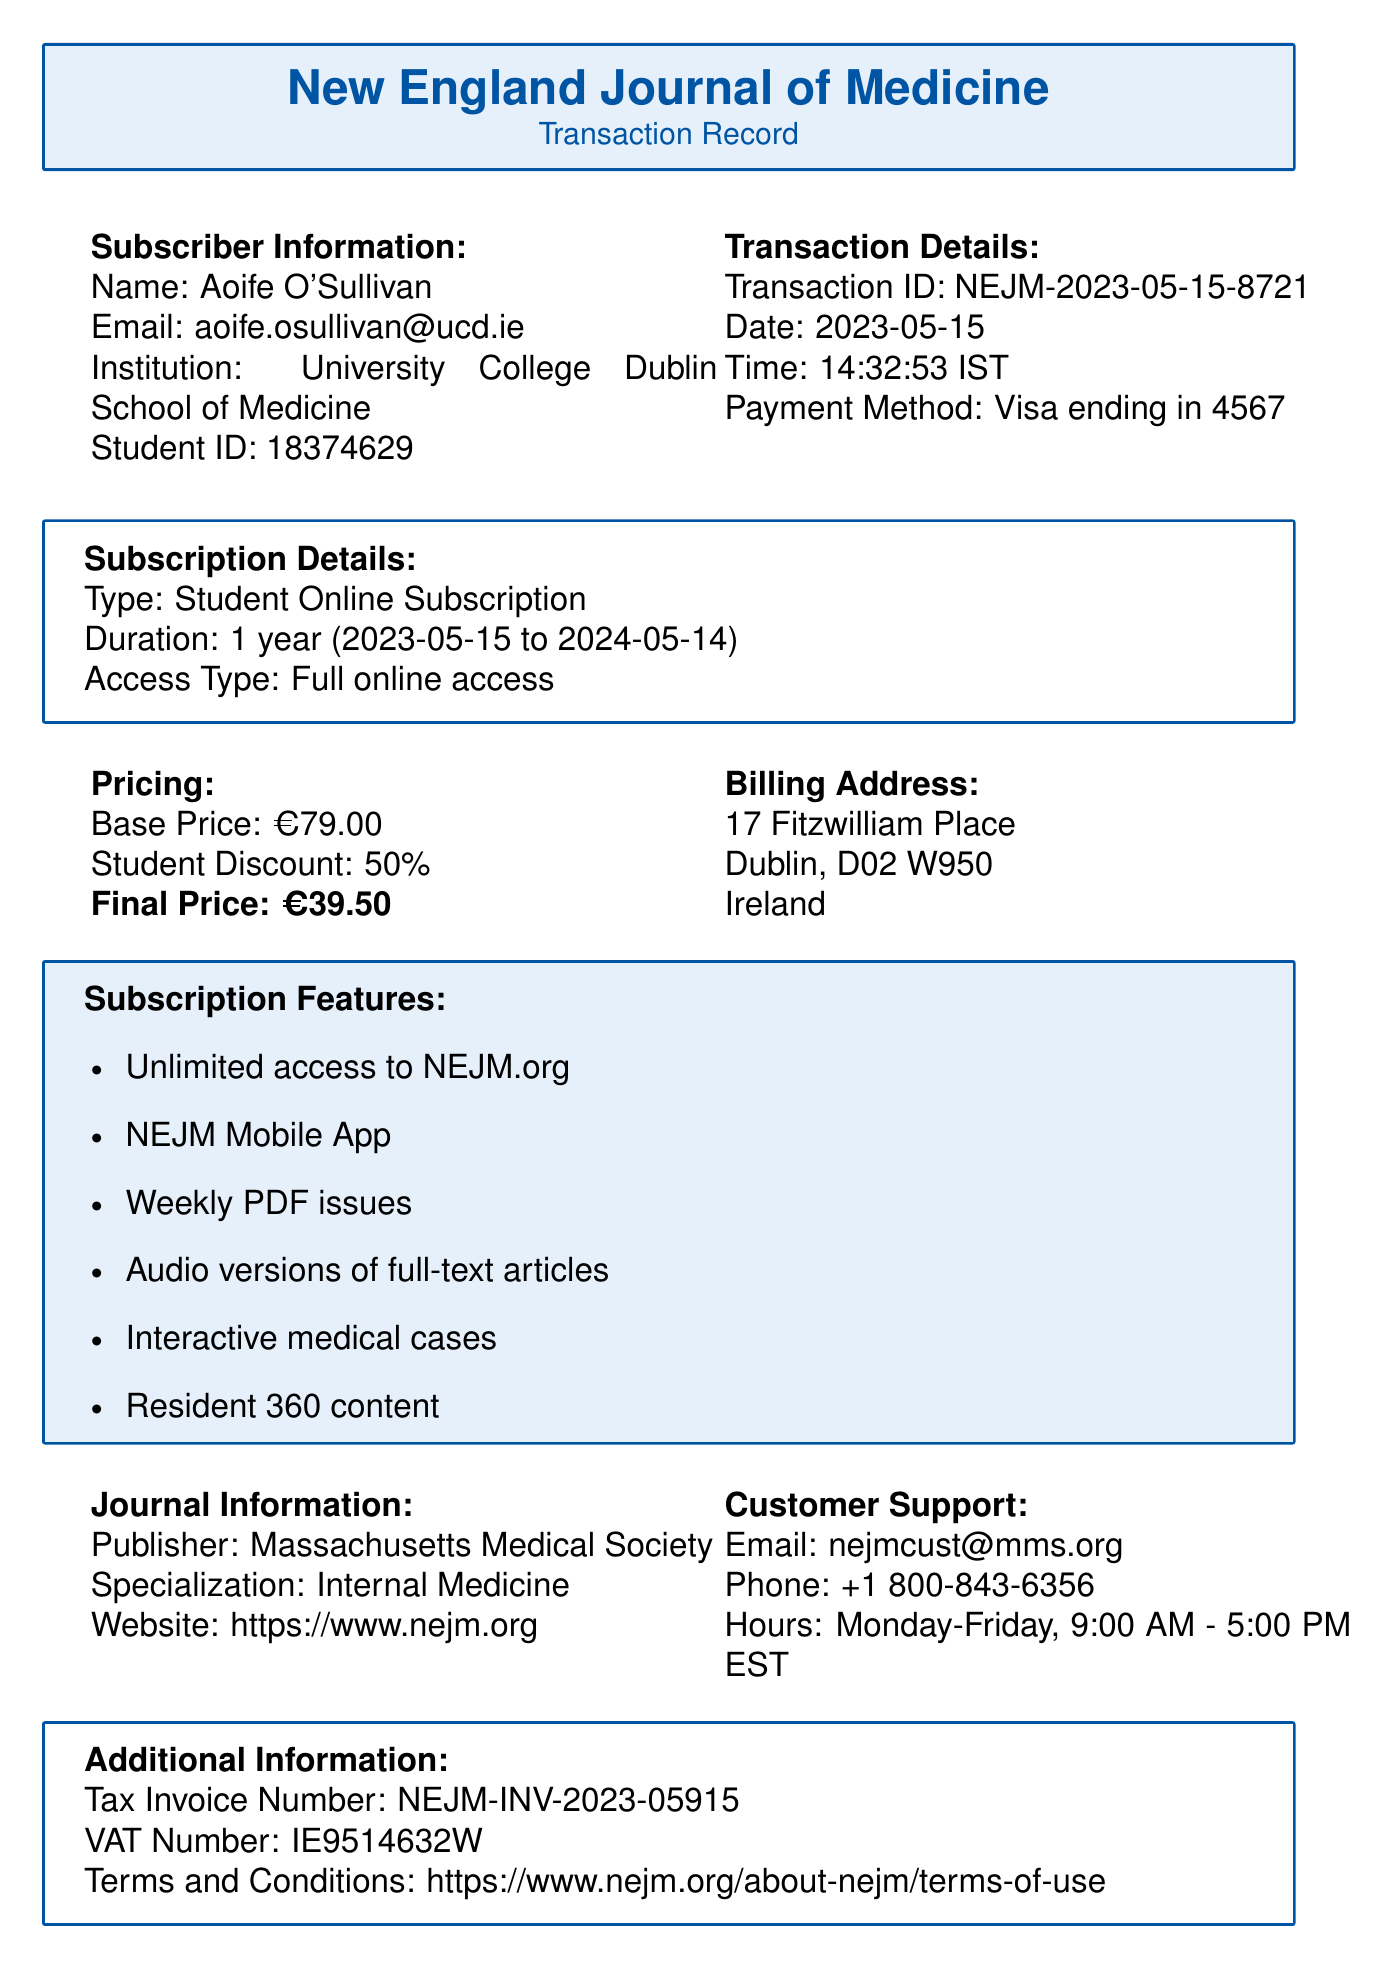what is the transaction ID? The transaction ID is a unique identifier for the transaction provided in the document.
Answer: NEJM-2023-05-15-8721 who is the subscriber? The subscriber's information includes their name, which is found in the document.
Answer: Aoife O'Sullivan what is the subscription type? The subscription type is specified in the document under subscription details.
Answer: Student Online Subscription what is the final price after discount? The final price is stated in the pricing section of the document.
Answer: €39.50 when does the subscription end? The end date of the subscription is clearly mentioned in the subscription details of the document.
Answer: 2024-05-14 which publisher produces the journal? The publisher's name is found in the journal information section of the document.
Answer: Massachusetts Medical Society how much is the student discount? The student discount percentage is specified in the pricing section.
Answer: 50% what is included in the subscription features? The subscription features are listed in the document, showcasing what subscribers get.
Answer: Unlimited access to NEJM.org what is the billing address? The billing address is a specific portion of the document with clear details.
Answer: 17 Fitzwilliam Place, Dublin, D02 W950, Ireland 